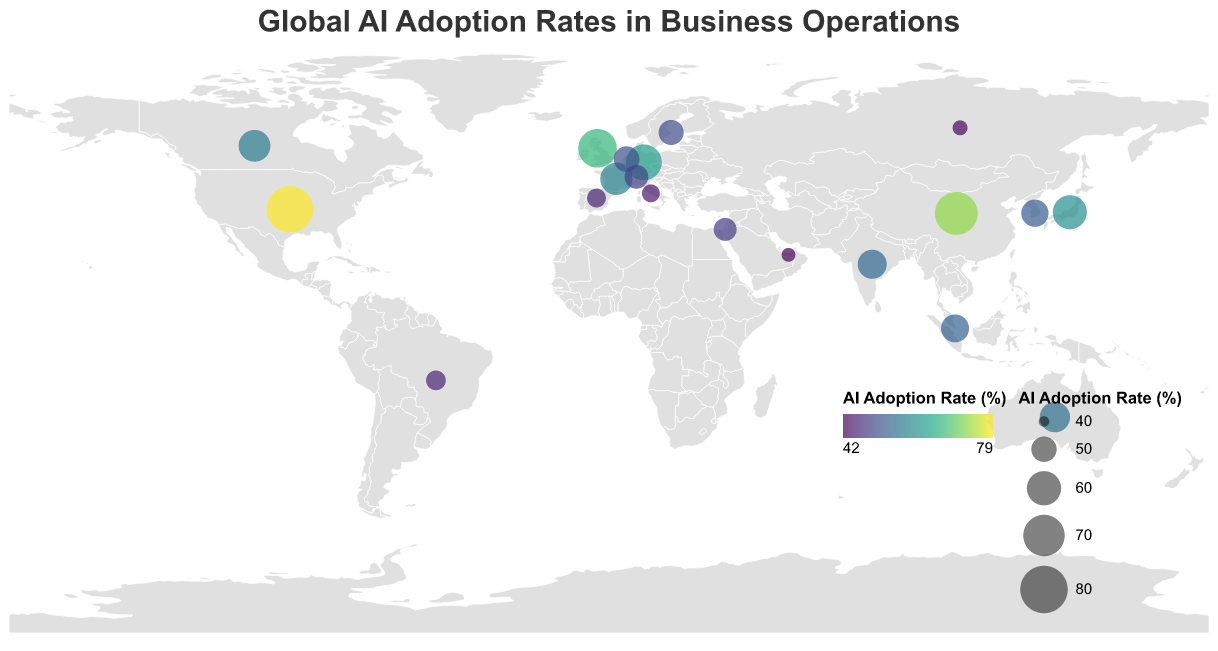Which country has the highest AI adoption rate? The figure shows circles of varying sizes and colors representing different AI adoption rates in each country. The largest and deepest colored circle corresponds to the highest adoption rate, which is the United States.
Answer: United States Which countries have an AI adoption rate above 70%? We identify circles on the map with sizes and colors that match an AI adoption rate above 70%. These countries are the ones with the largest and darkest colored circles. They include the United States and China.
Answer: United States, China What is the average AI adoption rate of the top five countries? Calculate the average by summing the adoption rates of the five countries with the highest values (United States: 78.5, China: 72.3, United Kingdom: 65.8, Germany: 62.1, Japan: 59.7) and dividing by five. The total is 78.5 + 72.3 + 65.8 + 62.1 + 59.7 = 338.4. Dividing by 5 gives 67.68.
Answer: 67.68 Which continents have the highest concentration of countries with AI adoption rates above 50%? Count and compare the number of countries with AI adoption rates above 50% on each continent. Europe and Asia have several countries with high rates (e.g., United Kingdom, Germany, France in Europe and China, Japan, South Korea in Asia).
Answer: Europe, Asia How does the AI adoption rate of Brazil compare to the average AI adoption rate of all countries listed? First, calculate the average AI adoption rate for all countries. Sum up the adoption rates of all countries and divide by the number of countries (20). The total is 1110.7, so the average is 1110.7 / 20 = 55.535. Brazil's rate is 45.2, which is below the average.
Answer: Below average How many countries have AI adoption rates between 50% and 60%? Identify and count the circles representing AI adoption rates between 50% and 60% including: Japan (59.7), France (57.4), Canada (56.9), Australia (55.2), India (53.8), Singapore (52.6), and South Korea (51.9).
Answer: 7 What's the total AI adoption rate of European countries listed in the figure? Sum the AI adoption rates of European countries: United Kingdom (65.8), Germany (62.1), France (57.4), Netherlands (50.3), Sweden (49.7), Switzerland (48.5), Spain (44.6), Italy (43.9), Russia (42.1). The total is 65.8 + 62.1 + 57.4 + 50.3 + 49.7 + 48.5 + 44.6 + 43.9 + 42.1 = 464.4.
Answer: 464.4 Which country in Africa has the highest AI adoption rate, and what is that rate? According to the provided data, no African country is listed in the figure, so there is no AI adoption rate provided for any African country.
Answer: Not Available 